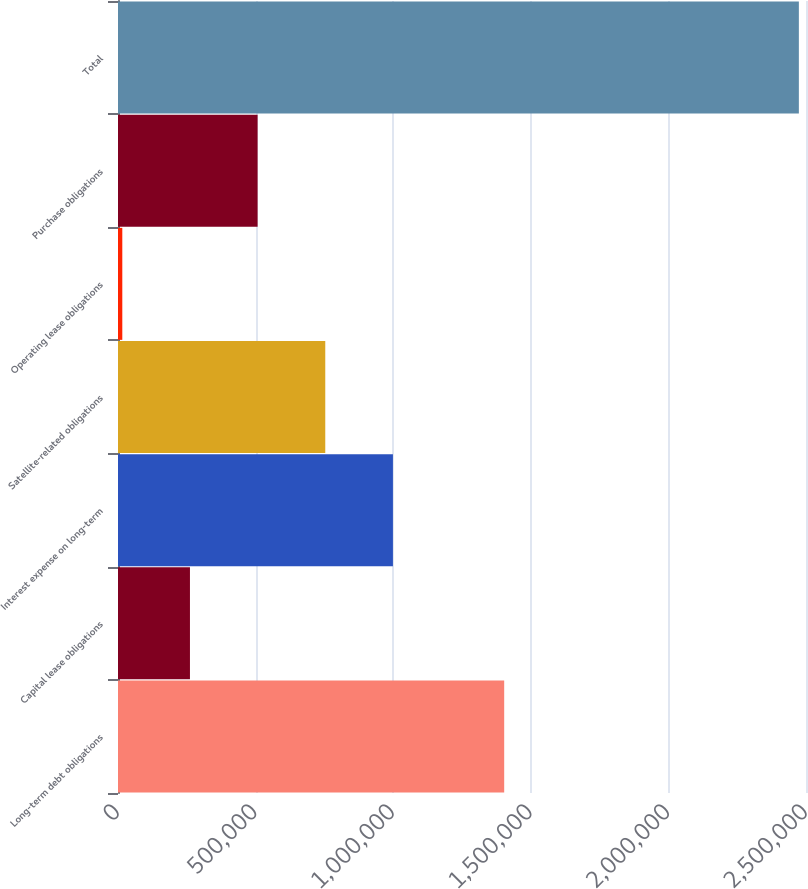Convert chart. <chart><loc_0><loc_0><loc_500><loc_500><bar_chart><fcel>Long-term debt obligations<fcel>Capital lease obligations<fcel>Interest expense on long-term<fcel>Satellite-related obligations<fcel>Operating lease obligations<fcel>Purchase obligations<fcel>Total<nl><fcel>1.4033e+06<fcel>261467<fcel>998999<fcel>753155<fcel>15623<fcel>507311<fcel>2.47406e+06<nl></chart> 